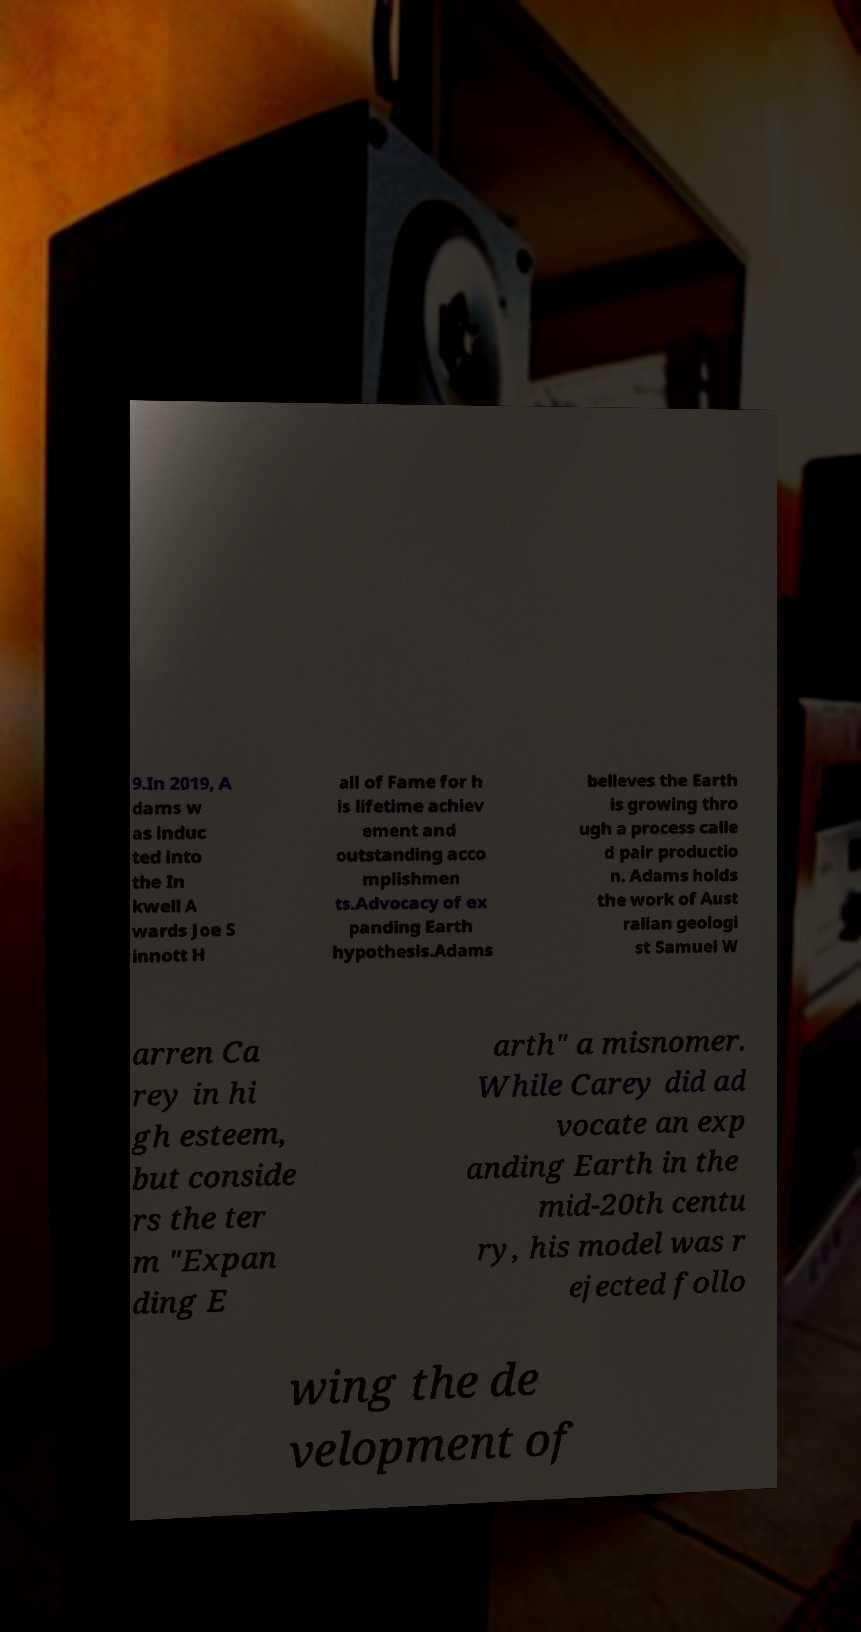What messages or text are displayed in this image? I need them in a readable, typed format. 9.In 2019, A dams w as induc ted into the In kwell A wards Joe S innott H all of Fame for h is lifetime achiev ement and outstanding acco mplishmen ts.Advocacy of ex panding Earth hypothesis.Adams believes the Earth is growing thro ugh a process calle d pair productio n. Adams holds the work of Aust ralian geologi st Samuel W arren Ca rey in hi gh esteem, but conside rs the ter m "Expan ding E arth" a misnomer. While Carey did ad vocate an exp anding Earth in the mid-20th centu ry, his model was r ejected follo wing the de velopment of 